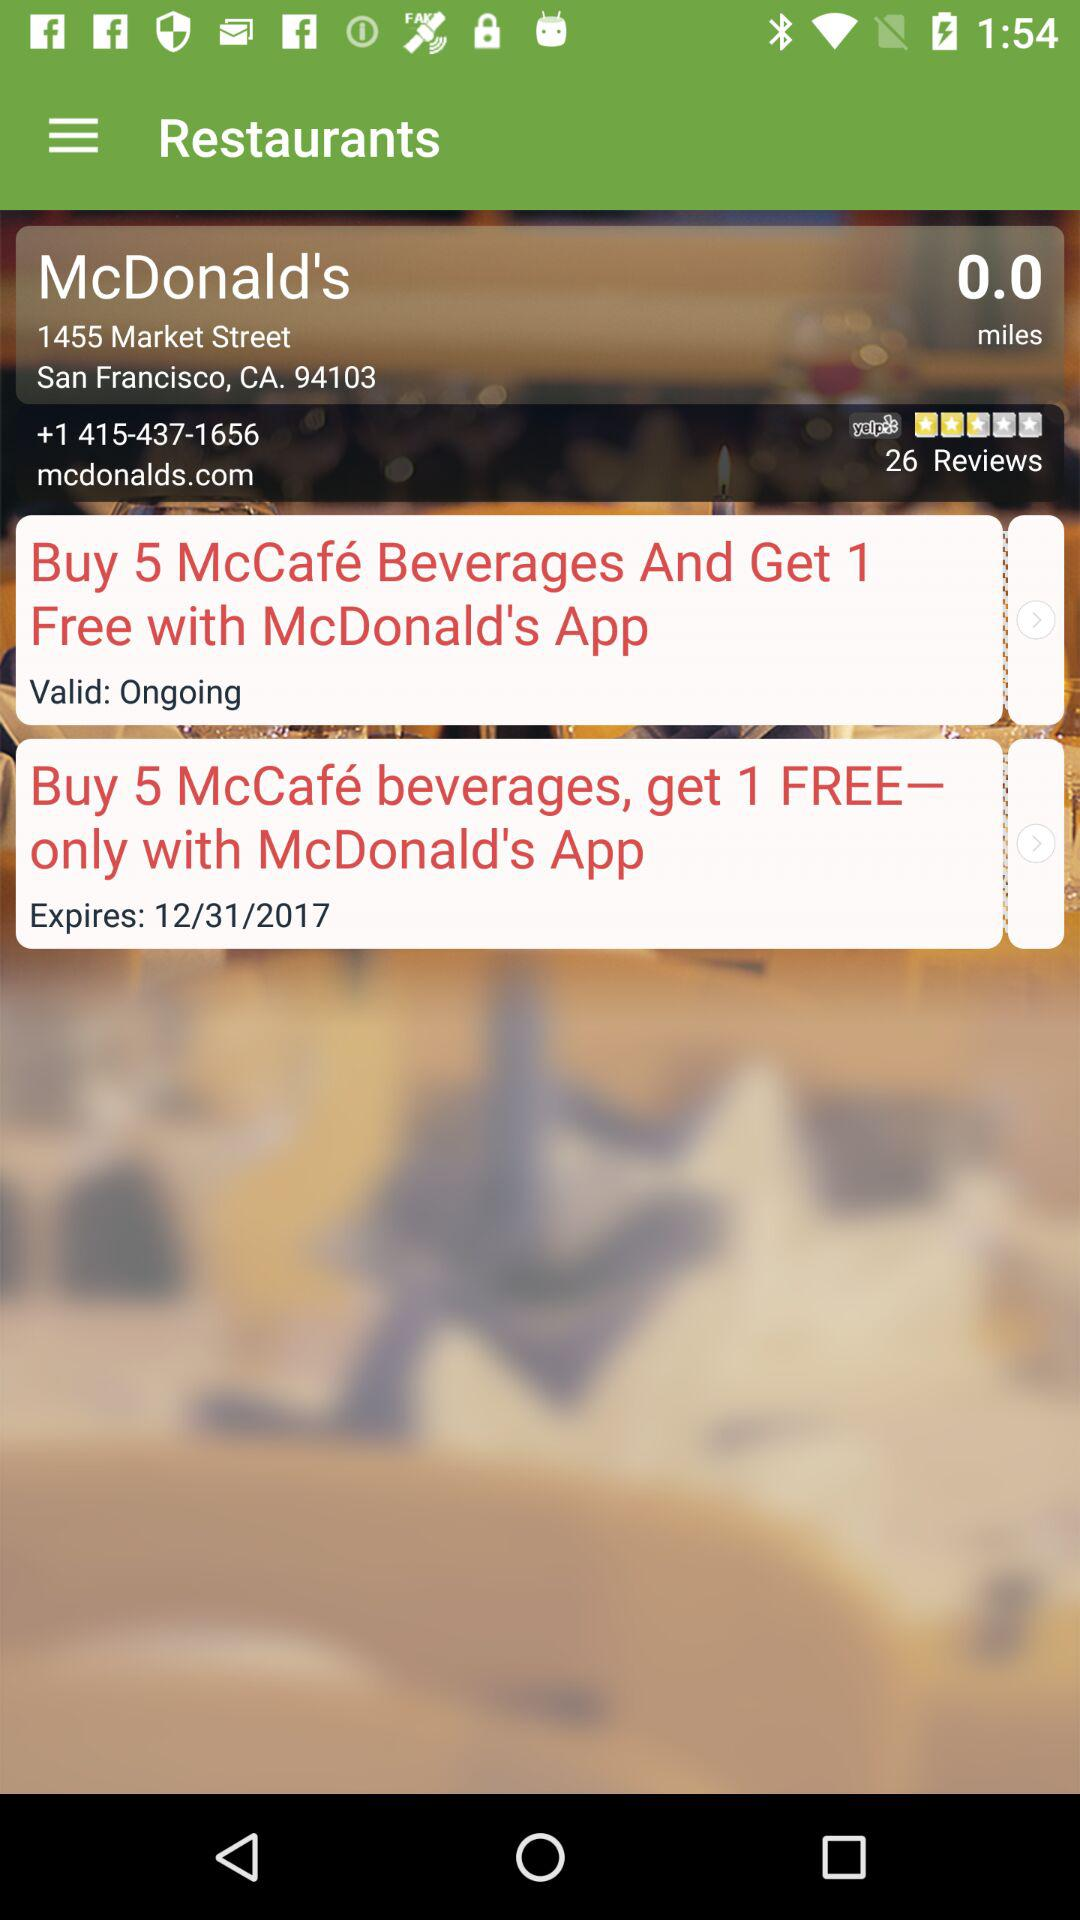What is the address of "McDonald's"? The address of "McDonald's" is 1455 Market Street, San Francisco, CA 94103. 